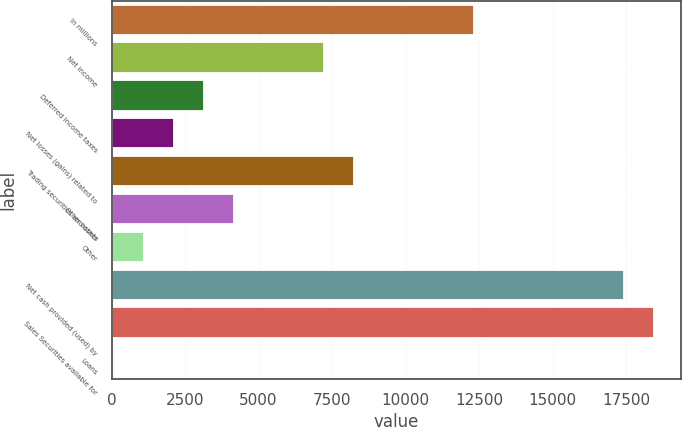Convert chart. <chart><loc_0><loc_0><loc_500><loc_500><bar_chart><fcel>In millions<fcel>Net income<fcel>Deferred income taxes<fcel>Net losses (gains) related to<fcel>Trading securities and other<fcel>Other assets<fcel>Other<fcel>Net cash provided (used) by<fcel>Sales Securities available for<fcel>Loans<nl><fcel>12324.4<fcel>7220.9<fcel>3138.1<fcel>2117.4<fcel>8241.6<fcel>4158.8<fcel>1096.7<fcel>17427.9<fcel>18448.6<fcel>76<nl></chart> 